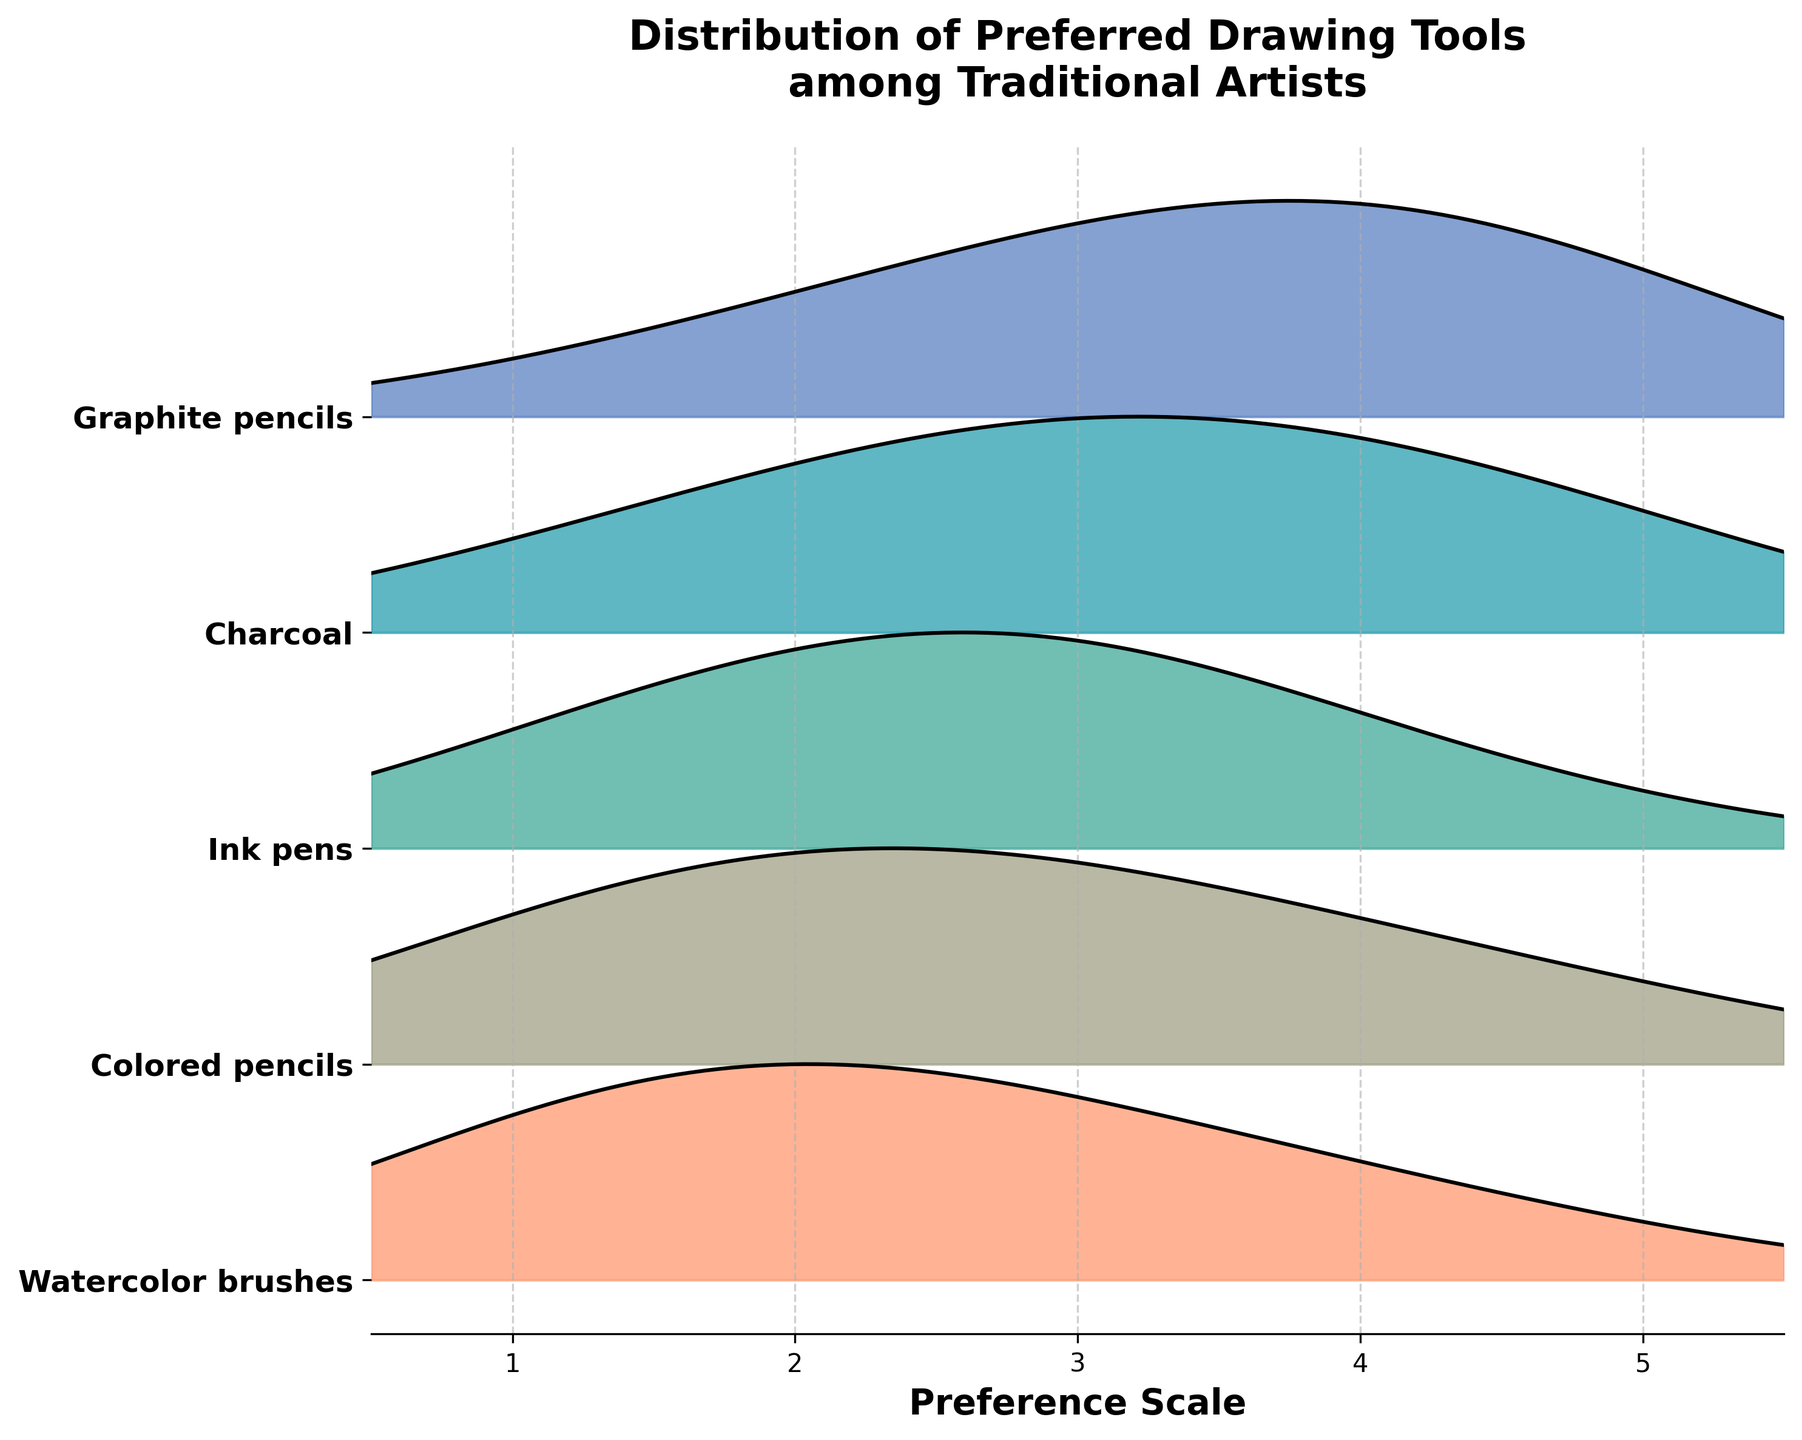How many drawing tools are shown on the Ridgeline plot? The y-axis labels represent the different drawing tools. To get the total number, count the unique labels listed on the y-axis.
Answer: 5 Which drawing tool has the highest peak density? The drawing tool with the highest peak density will have the tallest ridge in the plot. By visually comparing the ridges' heights, you can determine the tool with the peak density.
Answer: Graphite pencils What is the preferred value for Graphite pencils with the highest density? To identify the preferred value with the highest density for Graphite pencils, look for the peak of the ridge for Graphite pencils on the x-axis.
Answer: 4 Compare the distributions of Charcoal and Ink pens. Which one has a higher peak on the preference scale of 3? You need to locate the density peaks for Charcoal and Ink pens at the preference scale value of 3 and compare their heights at this point.
Answer: Ink pens Which tool has the most uniform distribution across the preference scale? To identify the tool with the most uniform distribution, look for the ridge that shows the least variation in height across the preference scale, indicating a more even density.
Answer: Colored pencils What is the median preference value for Watercolor brushes? The median value can be estimated by looking for the midpoint or the tallest peak of the ridge for Watercolor brushes. Since the distribution is skewed towards lower values, identify the peak and equidistant points.
Answer: 2 Is the peak density for Ink pens higher than for Colored pencils? Compare the peak heights of the ridges for Ink pens and Colored pencils by observing their maximum points on the plot. The taller ridge represents the higher peak density.
Answer: Yes Which drawing tool shows a preference peak at value 1? Identify which ridges have a noticeable peak around the value of 1 on the x-axis to determine the tools with a preference for this value.
Answer: Watercolor brushes 